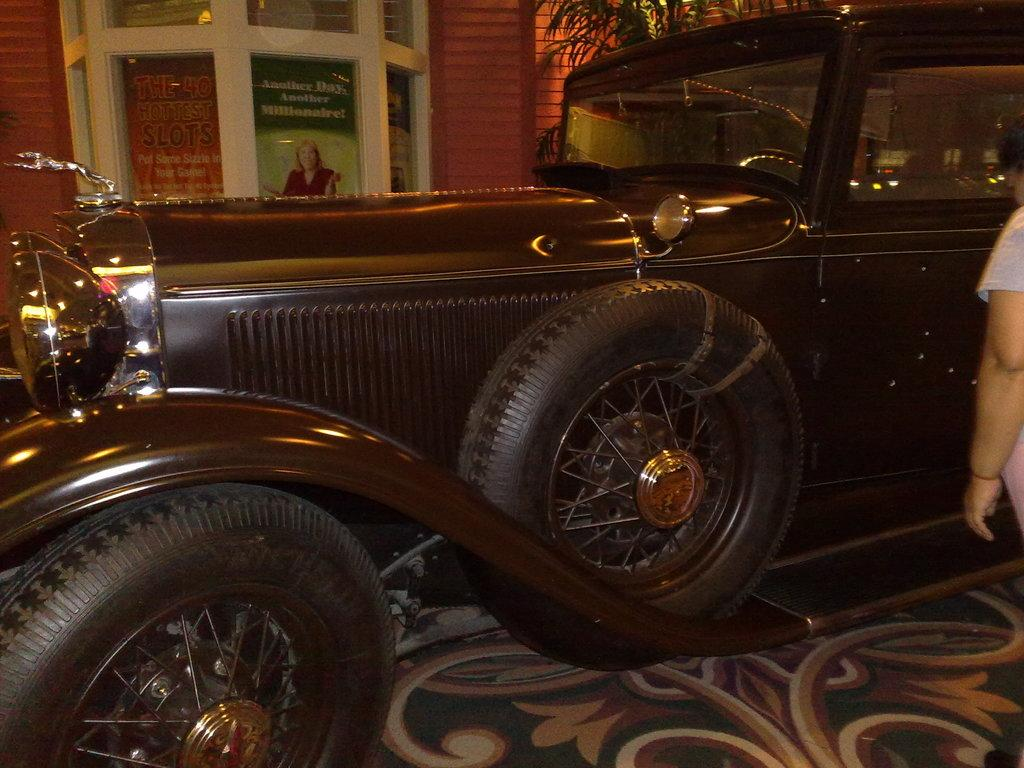What type of vehicle is in the image? There is an old vintage car in the image. Who or what is near the car? A person is standing beside the car. What can be seen on the other side of the car? There is a glass window on the wall on the other side of the car. What invention is being demonstrated by the person standing beside the car? There is no invention being demonstrated in the image; the person is simply standing beside the car. 